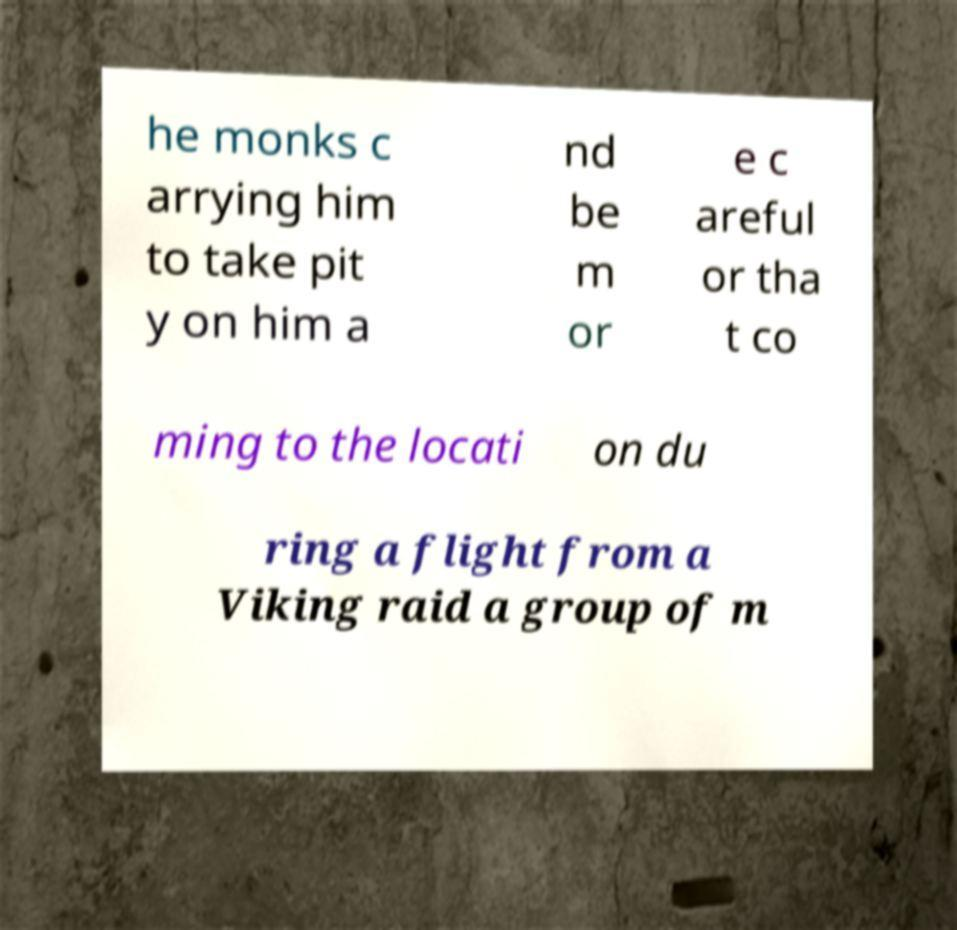Can you read and provide the text displayed in the image?This photo seems to have some interesting text. Can you extract and type it out for me? he monks c arrying him to take pit y on him a nd be m or e c areful or tha t co ming to the locati on du ring a flight from a Viking raid a group of m 